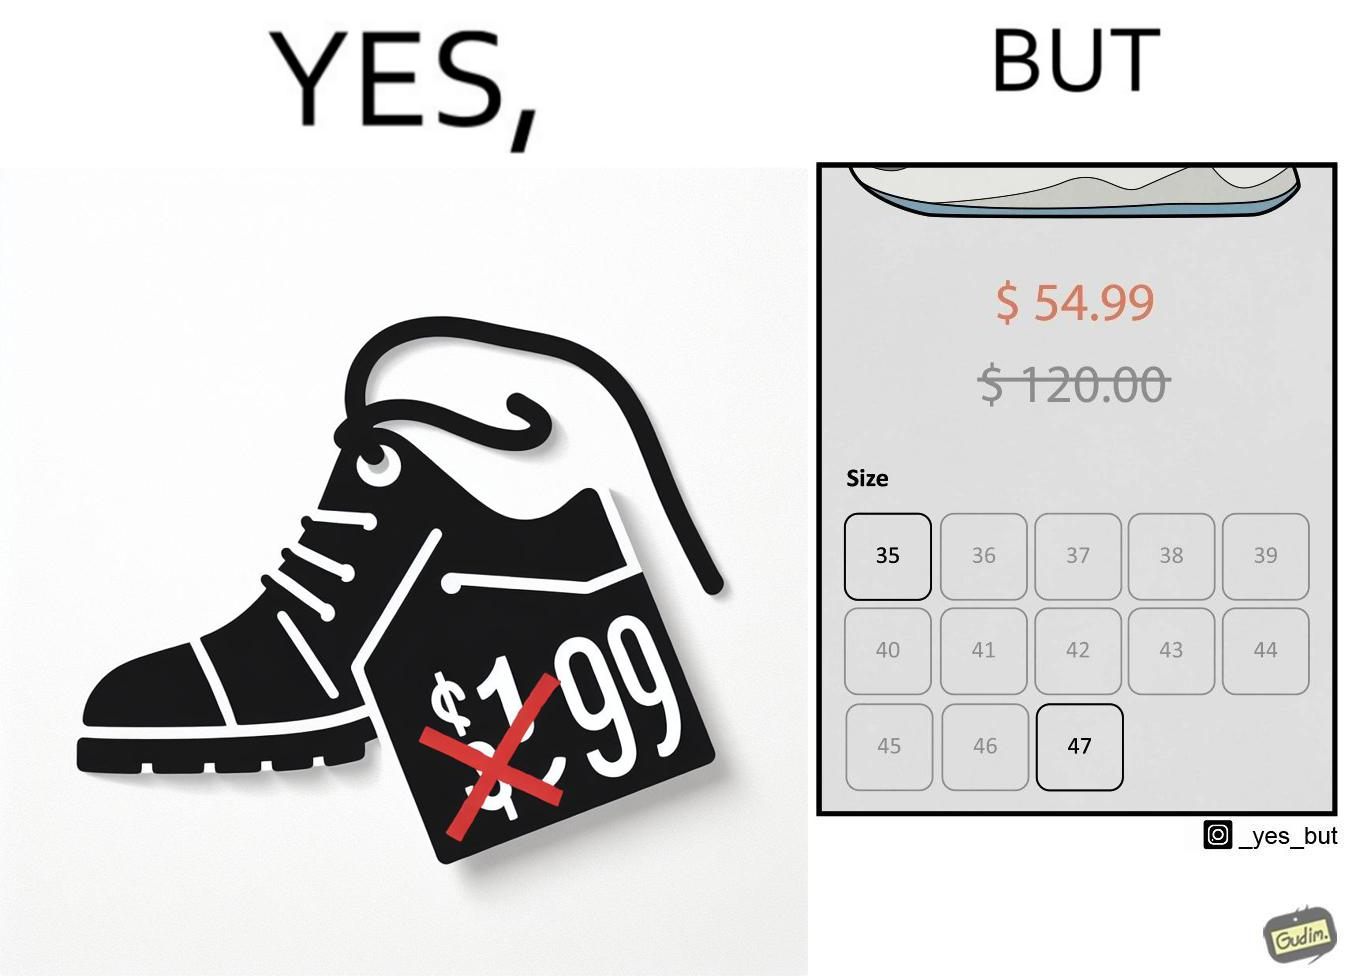What is shown in this image? The image is funny because while there is a big discount on the shoes inticing customer to buy them, the only available sizes are 35 and 47 which are the smalles and the largest meaning that a majority of the people can not buy the shoe because they won't fit. 